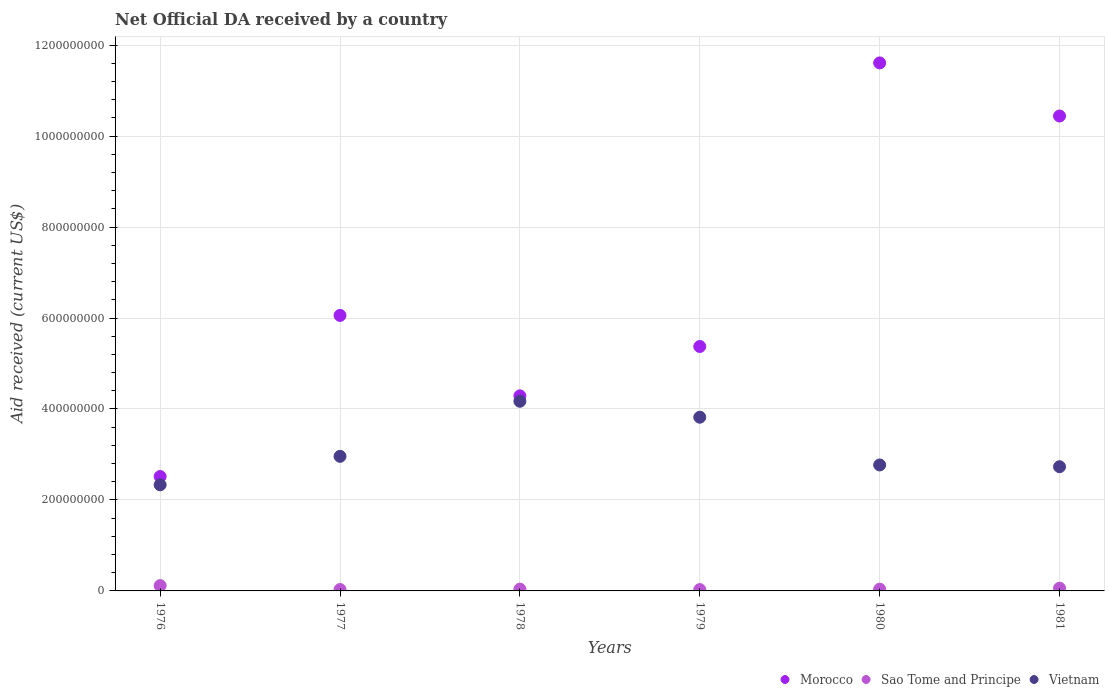Is the number of dotlines equal to the number of legend labels?
Your answer should be compact. Yes. What is the net official development assistance aid received in Sao Tome and Principe in 1980?
Your answer should be very brief. 3.82e+06. Across all years, what is the maximum net official development assistance aid received in Sao Tome and Principe?
Offer a terse response. 1.16e+07. Across all years, what is the minimum net official development assistance aid received in Sao Tome and Principe?
Make the answer very short. 2.95e+06. In which year was the net official development assistance aid received in Vietnam maximum?
Offer a very short reply. 1978. In which year was the net official development assistance aid received in Vietnam minimum?
Provide a short and direct response. 1976. What is the total net official development assistance aid received in Vietnam in the graph?
Give a very brief answer. 1.88e+09. What is the difference between the net official development assistance aid received in Morocco in 1979 and that in 1981?
Your response must be concise. -5.07e+08. What is the difference between the net official development assistance aid received in Vietnam in 1979 and the net official development assistance aid received in Sao Tome and Principe in 1980?
Keep it short and to the point. 3.78e+08. What is the average net official development assistance aid received in Vietnam per year?
Your response must be concise. 3.13e+08. In the year 1976, what is the difference between the net official development assistance aid received in Morocco and net official development assistance aid received in Vietnam?
Provide a short and direct response. 1.82e+07. What is the ratio of the net official development assistance aid received in Morocco in 1977 to that in 1978?
Ensure brevity in your answer.  1.41. Is the difference between the net official development assistance aid received in Morocco in 1976 and 1979 greater than the difference between the net official development assistance aid received in Vietnam in 1976 and 1979?
Make the answer very short. No. What is the difference between the highest and the second highest net official development assistance aid received in Vietnam?
Your answer should be very brief. 3.50e+07. What is the difference between the highest and the lowest net official development assistance aid received in Morocco?
Your answer should be compact. 9.09e+08. Is the sum of the net official development assistance aid received in Vietnam in 1976 and 1981 greater than the maximum net official development assistance aid received in Morocco across all years?
Your response must be concise. No. What is the difference between two consecutive major ticks on the Y-axis?
Provide a short and direct response. 2.00e+08. Are the values on the major ticks of Y-axis written in scientific E-notation?
Provide a short and direct response. No. Does the graph contain grids?
Give a very brief answer. Yes. What is the title of the graph?
Keep it short and to the point. Net Official DA received by a country. What is the label or title of the X-axis?
Give a very brief answer. Years. What is the label or title of the Y-axis?
Provide a short and direct response. Aid received (current US$). What is the Aid received (current US$) of Morocco in 1976?
Keep it short and to the point. 2.52e+08. What is the Aid received (current US$) of Sao Tome and Principe in 1976?
Make the answer very short. 1.16e+07. What is the Aid received (current US$) in Vietnam in 1976?
Offer a terse response. 2.33e+08. What is the Aid received (current US$) in Morocco in 1977?
Your answer should be compact. 6.06e+08. What is the Aid received (current US$) in Sao Tome and Principe in 1977?
Provide a succinct answer. 3.04e+06. What is the Aid received (current US$) of Vietnam in 1977?
Your answer should be very brief. 2.96e+08. What is the Aid received (current US$) of Morocco in 1978?
Provide a short and direct response. 4.29e+08. What is the Aid received (current US$) of Sao Tome and Principe in 1978?
Make the answer very short. 3.98e+06. What is the Aid received (current US$) of Vietnam in 1978?
Provide a short and direct response. 4.17e+08. What is the Aid received (current US$) of Morocco in 1979?
Your response must be concise. 5.37e+08. What is the Aid received (current US$) of Sao Tome and Principe in 1979?
Your response must be concise. 2.95e+06. What is the Aid received (current US$) in Vietnam in 1979?
Offer a very short reply. 3.82e+08. What is the Aid received (current US$) of Morocco in 1980?
Provide a succinct answer. 1.16e+09. What is the Aid received (current US$) of Sao Tome and Principe in 1980?
Make the answer very short. 3.82e+06. What is the Aid received (current US$) in Vietnam in 1980?
Your answer should be very brief. 2.77e+08. What is the Aid received (current US$) in Morocco in 1981?
Make the answer very short. 1.04e+09. What is the Aid received (current US$) in Vietnam in 1981?
Ensure brevity in your answer.  2.73e+08. Across all years, what is the maximum Aid received (current US$) in Morocco?
Ensure brevity in your answer.  1.16e+09. Across all years, what is the maximum Aid received (current US$) in Sao Tome and Principe?
Provide a succinct answer. 1.16e+07. Across all years, what is the maximum Aid received (current US$) of Vietnam?
Ensure brevity in your answer.  4.17e+08. Across all years, what is the minimum Aid received (current US$) in Morocco?
Give a very brief answer. 2.52e+08. Across all years, what is the minimum Aid received (current US$) in Sao Tome and Principe?
Your response must be concise. 2.95e+06. Across all years, what is the minimum Aid received (current US$) of Vietnam?
Your response must be concise. 2.33e+08. What is the total Aid received (current US$) in Morocco in the graph?
Your answer should be very brief. 4.03e+09. What is the total Aid received (current US$) in Sao Tome and Principe in the graph?
Ensure brevity in your answer.  3.14e+07. What is the total Aid received (current US$) of Vietnam in the graph?
Your answer should be very brief. 1.88e+09. What is the difference between the Aid received (current US$) in Morocco in 1976 and that in 1977?
Ensure brevity in your answer.  -3.54e+08. What is the difference between the Aid received (current US$) in Sao Tome and Principe in 1976 and that in 1977?
Provide a succinct answer. 8.61e+06. What is the difference between the Aid received (current US$) of Vietnam in 1976 and that in 1977?
Your answer should be very brief. -6.26e+07. What is the difference between the Aid received (current US$) in Morocco in 1976 and that in 1978?
Your answer should be compact. -1.77e+08. What is the difference between the Aid received (current US$) in Sao Tome and Principe in 1976 and that in 1978?
Your response must be concise. 7.67e+06. What is the difference between the Aid received (current US$) of Vietnam in 1976 and that in 1978?
Give a very brief answer. -1.84e+08. What is the difference between the Aid received (current US$) in Morocco in 1976 and that in 1979?
Offer a terse response. -2.86e+08. What is the difference between the Aid received (current US$) of Sao Tome and Principe in 1976 and that in 1979?
Make the answer very short. 8.70e+06. What is the difference between the Aid received (current US$) in Vietnam in 1976 and that in 1979?
Your answer should be very brief. -1.49e+08. What is the difference between the Aid received (current US$) of Morocco in 1976 and that in 1980?
Ensure brevity in your answer.  -9.09e+08. What is the difference between the Aid received (current US$) in Sao Tome and Principe in 1976 and that in 1980?
Provide a short and direct response. 7.83e+06. What is the difference between the Aid received (current US$) in Vietnam in 1976 and that in 1980?
Your response must be concise. -4.36e+07. What is the difference between the Aid received (current US$) in Morocco in 1976 and that in 1981?
Provide a short and direct response. -7.93e+08. What is the difference between the Aid received (current US$) of Sao Tome and Principe in 1976 and that in 1981?
Give a very brief answer. 5.65e+06. What is the difference between the Aid received (current US$) of Vietnam in 1976 and that in 1981?
Your answer should be very brief. -3.98e+07. What is the difference between the Aid received (current US$) of Morocco in 1977 and that in 1978?
Your answer should be very brief. 1.77e+08. What is the difference between the Aid received (current US$) of Sao Tome and Principe in 1977 and that in 1978?
Your response must be concise. -9.40e+05. What is the difference between the Aid received (current US$) of Vietnam in 1977 and that in 1978?
Offer a very short reply. -1.21e+08. What is the difference between the Aid received (current US$) in Morocco in 1977 and that in 1979?
Offer a terse response. 6.83e+07. What is the difference between the Aid received (current US$) in Sao Tome and Principe in 1977 and that in 1979?
Ensure brevity in your answer.  9.00e+04. What is the difference between the Aid received (current US$) of Vietnam in 1977 and that in 1979?
Give a very brief answer. -8.60e+07. What is the difference between the Aid received (current US$) of Morocco in 1977 and that in 1980?
Offer a very short reply. -5.55e+08. What is the difference between the Aid received (current US$) of Sao Tome and Principe in 1977 and that in 1980?
Your answer should be compact. -7.80e+05. What is the difference between the Aid received (current US$) of Vietnam in 1977 and that in 1980?
Provide a short and direct response. 1.90e+07. What is the difference between the Aid received (current US$) in Morocco in 1977 and that in 1981?
Provide a succinct answer. -4.38e+08. What is the difference between the Aid received (current US$) in Sao Tome and Principe in 1977 and that in 1981?
Offer a terse response. -2.96e+06. What is the difference between the Aid received (current US$) of Vietnam in 1977 and that in 1981?
Give a very brief answer. 2.28e+07. What is the difference between the Aid received (current US$) of Morocco in 1978 and that in 1979?
Ensure brevity in your answer.  -1.09e+08. What is the difference between the Aid received (current US$) in Sao Tome and Principe in 1978 and that in 1979?
Give a very brief answer. 1.03e+06. What is the difference between the Aid received (current US$) of Vietnam in 1978 and that in 1979?
Make the answer very short. 3.50e+07. What is the difference between the Aid received (current US$) in Morocco in 1978 and that in 1980?
Keep it short and to the point. -7.32e+08. What is the difference between the Aid received (current US$) in Vietnam in 1978 and that in 1980?
Make the answer very short. 1.40e+08. What is the difference between the Aid received (current US$) in Morocco in 1978 and that in 1981?
Your response must be concise. -6.15e+08. What is the difference between the Aid received (current US$) of Sao Tome and Principe in 1978 and that in 1981?
Ensure brevity in your answer.  -2.02e+06. What is the difference between the Aid received (current US$) of Vietnam in 1978 and that in 1981?
Keep it short and to the point. 1.44e+08. What is the difference between the Aid received (current US$) of Morocco in 1979 and that in 1980?
Ensure brevity in your answer.  -6.23e+08. What is the difference between the Aid received (current US$) of Sao Tome and Principe in 1979 and that in 1980?
Ensure brevity in your answer.  -8.70e+05. What is the difference between the Aid received (current US$) of Vietnam in 1979 and that in 1980?
Offer a very short reply. 1.05e+08. What is the difference between the Aid received (current US$) in Morocco in 1979 and that in 1981?
Ensure brevity in your answer.  -5.07e+08. What is the difference between the Aid received (current US$) of Sao Tome and Principe in 1979 and that in 1981?
Offer a very short reply. -3.05e+06. What is the difference between the Aid received (current US$) of Vietnam in 1979 and that in 1981?
Offer a very short reply. 1.09e+08. What is the difference between the Aid received (current US$) in Morocco in 1980 and that in 1981?
Your answer should be very brief. 1.17e+08. What is the difference between the Aid received (current US$) of Sao Tome and Principe in 1980 and that in 1981?
Your response must be concise. -2.18e+06. What is the difference between the Aid received (current US$) in Vietnam in 1980 and that in 1981?
Make the answer very short. 3.85e+06. What is the difference between the Aid received (current US$) of Morocco in 1976 and the Aid received (current US$) of Sao Tome and Principe in 1977?
Give a very brief answer. 2.48e+08. What is the difference between the Aid received (current US$) in Morocco in 1976 and the Aid received (current US$) in Vietnam in 1977?
Give a very brief answer. -4.44e+07. What is the difference between the Aid received (current US$) of Sao Tome and Principe in 1976 and the Aid received (current US$) of Vietnam in 1977?
Give a very brief answer. -2.84e+08. What is the difference between the Aid received (current US$) in Morocco in 1976 and the Aid received (current US$) in Sao Tome and Principe in 1978?
Your response must be concise. 2.48e+08. What is the difference between the Aid received (current US$) in Morocco in 1976 and the Aid received (current US$) in Vietnam in 1978?
Offer a very short reply. -1.65e+08. What is the difference between the Aid received (current US$) of Sao Tome and Principe in 1976 and the Aid received (current US$) of Vietnam in 1978?
Give a very brief answer. -4.05e+08. What is the difference between the Aid received (current US$) of Morocco in 1976 and the Aid received (current US$) of Sao Tome and Principe in 1979?
Offer a terse response. 2.49e+08. What is the difference between the Aid received (current US$) of Morocco in 1976 and the Aid received (current US$) of Vietnam in 1979?
Provide a succinct answer. -1.30e+08. What is the difference between the Aid received (current US$) of Sao Tome and Principe in 1976 and the Aid received (current US$) of Vietnam in 1979?
Provide a succinct answer. -3.70e+08. What is the difference between the Aid received (current US$) of Morocco in 1976 and the Aid received (current US$) of Sao Tome and Principe in 1980?
Your response must be concise. 2.48e+08. What is the difference between the Aid received (current US$) in Morocco in 1976 and the Aid received (current US$) in Vietnam in 1980?
Offer a very short reply. -2.54e+07. What is the difference between the Aid received (current US$) of Sao Tome and Principe in 1976 and the Aid received (current US$) of Vietnam in 1980?
Provide a short and direct response. -2.65e+08. What is the difference between the Aid received (current US$) of Morocco in 1976 and the Aid received (current US$) of Sao Tome and Principe in 1981?
Offer a terse response. 2.46e+08. What is the difference between the Aid received (current US$) in Morocco in 1976 and the Aid received (current US$) in Vietnam in 1981?
Offer a terse response. -2.16e+07. What is the difference between the Aid received (current US$) of Sao Tome and Principe in 1976 and the Aid received (current US$) of Vietnam in 1981?
Your response must be concise. -2.61e+08. What is the difference between the Aid received (current US$) of Morocco in 1977 and the Aid received (current US$) of Sao Tome and Principe in 1978?
Keep it short and to the point. 6.02e+08. What is the difference between the Aid received (current US$) of Morocco in 1977 and the Aid received (current US$) of Vietnam in 1978?
Your answer should be very brief. 1.89e+08. What is the difference between the Aid received (current US$) in Sao Tome and Principe in 1977 and the Aid received (current US$) in Vietnam in 1978?
Ensure brevity in your answer.  -4.14e+08. What is the difference between the Aid received (current US$) in Morocco in 1977 and the Aid received (current US$) in Sao Tome and Principe in 1979?
Your answer should be very brief. 6.03e+08. What is the difference between the Aid received (current US$) of Morocco in 1977 and the Aid received (current US$) of Vietnam in 1979?
Provide a short and direct response. 2.24e+08. What is the difference between the Aid received (current US$) of Sao Tome and Principe in 1977 and the Aid received (current US$) of Vietnam in 1979?
Provide a succinct answer. -3.79e+08. What is the difference between the Aid received (current US$) of Morocco in 1977 and the Aid received (current US$) of Sao Tome and Principe in 1980?
Provide a short and direct response. 6.02e+08. What is the difference between the Aid received (current US$) in Morocco in 1977 and the Aid received (current US$) in Vietnam in 1980?
Make the answer very short. 3.29e+08. What is the difference between the Aid received (current US$) of Sao Tome and Principe in 1977 and the Aid received (current US$) of Vietnam in 1980?
Offer a very short reply. -2.74e+08. What is the difference between the Aid received (current US$) in Morocco in 1977 and the Aid received (current US$) in Sao Tome and Principe in 1981?
Your answer should be compact. 6.00e+08. What is the difference between the Aid received (current US$) in Morocco in 1977 and the Aid received (current US$) in Vietnam in 1981?
Your answer should be very brief. 3.33e+08. What is the difference between the Aid received (current US$) in Sao Tome and Principe in 1977 and the Aid received (current US$) in Vietnam in 1981?
Your answer should be very brief. -2.70e+08. What is the difference between the Aid received (current US$) in Morocco in 1978 and the Aid received (current US$) in Sao Tome and Principe in 1979?
Your answer should be compact. 4.26e+08. What is the difference between the Aid received (current US$) of Morocco in 1978 and the Aid received (current US$) of Vietnam in 1979?
Offer a very short reply. 4.69e+07. What is the difference between the Aid received (current US$) in Sao Tome and Principe in 1978 and the Aid received (current US$) in Vietnam in 1979?
Keep it short and to the point. -3.78e+08. What is the difference between the Aid received (current US$) in Morocco in 1978 and the Aid received (current US$) in Sao Tome and Principe in 1980?
Make the answer very short. 4.25e+08. What is the difference between the Aid received (current US$) in Morocco in 1978 and the Aid received (current US$) in Vietnam in 1980?
Your response must be concise. 1.52e+08. What is the difference between the Aid received (current US$) in Sao Tome and Principe in 1978 and the Aid received (current US$) in Vietnam in 1980?
Offer a terse response. -2.73e+08. What is the difference between the Aid received (current US$) in Morocco in 1978 and the Aid received (current US$) in Sao Tome and Principe in 1981?
Make the answer very short. 4.23e+08. What is the difference between the Aid received (current US$) in Morocco in 1978 and the Aid received (current US$) in Vietnam in 1981?
Offer a terse response. 1.56e+08. What is the difference between the Aid received (current US$) of Sao Tome and Principe in 1978 and the Aid received (current US$) of Vietnam in 1981?
Provide a succinct answer. -2.69e+08. What is the difference between the Aid received (current US$) in Morocco in 1979 and the Aid received (current US$) in Sao Tome and Principe in 1980?
Provide a succinct answer. 5.34e+08. What is the difference between the Aid received (current US$) of Morocco in 1979 and the Aid received (current US$) of Vietnam in 1980?
Offer a terse response. 2.60e+08. What is the difference between the Aid received (current US$) in Sao Tome and Principe in 1979 and the Aid received (current US$) in Vietnam in 1980?
Provide a succinct answer. -2.74e+08. What is the difference between the Aid received (current US$) of Morocco in 1979 and the Aid received (current US$) of Sao Tome and Principe in 1981?
Offer a terse response. 5.31e+08. What is the difference between the Aid received (current US$) of Morocco in 1979 and the Aid received (current US$) of Vietnam in 1981?
Provide a succinct answer. 2.64e+08. What is the difference between the Aid received (current US$) of Sao Tome and Principe in 1979 and the Aid received (current US$) of Vietnam in 1981?
Your answer should be compact. -2.70e+08. What is the difference between the Aid received (current US$) of Morocco in 1980 and the Aid received (current US$) of Sao Tome and Principe in 1981?
Your answer should be compact. 1.15e+09. What is the difference between the Aid received (current US$) of Morocco in 1980 and the Aid received (current US$) of Vietnam in 1981?
Give a very brief answer. 8.88e+08. What is the difference between the Aid received (current US$) in Sao Tome and Principe in 1980 and the Aid received (current US$) in Vietnam in 1981?
Provide a succinct answer. -2.69e+08. What is the average Aid received (current US$) in Morocco per year?
Give a very brief answer. 6.71e+08. What is the average Aid received (current US$) in Sao Tome and Principe per year?
Provide a succinct answer. 5.24e+06. What is the average Aid received (current US$) of Vietnam per year?
Keep it short and to the point. 3.13e+08. In the year 1976, what is the difference between the Aid received (current US$) of Morocco and Aid received (current US$) of Sao Tome and Principe?
Make the answer very short. 2.40e+08. In the year 1976, what is the difference between the Aid received (current US$) in Morocco and Aid received (current US$) in Vietnam?
Ensure brevity in your answer.  1.82e+07. In the year 1976, what is the difference between the Aid received (current US$) of Sao Tome and Principe and Aid received (current US$) of Vietnam?
Provide a short and direct response. -2.22e+08. In the year 1977, what is the difference between the Aid received (current US$) of Morocco and Aid received (current US$) of Sao Tome and Principe?
Provide a succinct answer. 6.03e+08. In the year 1977, what is the difference between the Aid received (current US$) of Morocco and Aid received (current US$) of Vietnam?
Offer a very short reply. 3.10e+08. In the year 1977, what is the difference between the Aid received (current US$) of Sao Tome and Principe and Aid received (current US$) of Vietnam?
Your answer should be compact. -2.93e+08. In the year 1978, what is the difference between the Aid received (current US$) in Morocco and Aid received (current US$) in Sao Tome and Principe?
Offer a terse response. 4.25e+08. In the year 1978, what is the difference between the Aid received (current US$) in Morocco and Aid received (current US$) in Vietnam?
Provide a short and direct response. 1.19e+07. In the year 1978, what is the difference between the Aid received (current US$) of Sao Tome and Principe and Aid received (current US$) of Vietnam?
Ensure brevity in your answer.  -4.13e+08. In the year 1979, what is the difference between the Aid received (current US$) of Morocco and Aid received (current US$) of Sao Tome and Principe?
Keep it short and to the point. 5.34e+08. In the year 1979, what is the difference between the Aid received (current US$) in Morocco and Aid received (current US$) in Vietnam?
Your answer should be very brief. 1.55e+08. In the year 1979, what is the difference between the Aid received (current US$) of Sao Tome and Principe and Aid received (current US$) of Vietnam?
Make the answer very short. -3.79e+08. In the year 1980, what is the difference between the Aid received (current US$) of Morocco and Aid received (current US$) of Sao Tome and Principe?
Provide a succinct answer. 1.16e+09. In the year 1980, what is the difference between the Aid received (current US$) of Morocco and Aid received (current US$) of Vietnam?
Keep it short and to the point. 8.84e+08. In the year 1980, what is the difference between the Aid received (current US$) of Sao Tome and Principe and Aid received (current US$) of Vietnam?
Make the answer very short. -2.73e+08. In the year 1981, what is the difference between the Aid received (current US$) of Morocco and Aid received (current US$) of Sao Tome and Principe?
Give a very brief answer. 1.04e+09. In the year 1981, what is the difference between the Aid received (current US$) in Morocco and Aid received (current US$) in Vietnam?
Offer a very short reply. 7.71e+08. In the year 1981, what is the difference between the Aid received (current US$) of Sao Tome and Principe and Aid received (current US$) of Vietnam?
Your answer should be very brief. -2.67e+08. What is the ratio of the Aid received (current US$) of Morocco in 1976 to that in 1977?
Provide a succinct answer. 0.42. What is the ratio of the Aid received (current US$) in Sao Tome and Principe in 1976 to that in 1977?
Offer a very short reply. 3.83. What is the ratio of the Aid received (current US$) in Vietnam in 1976 to that in 1977?
Offer a very short reply. 0.79. What is the ratio of the Aid received (current US$) in Morocco in 1976 to that in 1978?
Your answer should be very brief. 0.59. What is the ratio of the Aid received (current US$) of Sao Tome and Principe in 1976 to that in 1978?
Make the answer very short. 2.93. What is the ratio of the Aid received (current US$) in Vietnam in 1976 to that in 1978?
Provide a succinct answer. 0.56. What is the ratio of the Aid received (current US$) in Morocco in 1976 to that in 1979?
Give a very brief answer. 0.47. What is the ratio of the Aid received (current US$) in Sao Tome and Principe in 1976 to that in 1979?
Make the answer very short. 3.95. What is the ratio of the Aid received (current US$) in Vietnam in 1976 to that in 1979?
Your answer should be compact. 0.61. What is the ratio of the Aid received (current US$) in Morocco in 1976 to that in 1980?
Your answer should be compact. 0.22. What is the ratio of the Aid received (current US$) of Sao Tome and Principe in 1976 to that in 1980?
Your answer should be compact. 3.05. What is the ratio of the Aid received (current US$) in Vietnam in 1976 to that in 1980?
Provide a succinct answer. 0.84. What is the ratio of the Aid received (current US$) of Morocco in 1976 to that in 1981?
Your answer should be very brief. 0.24. What is the ratio of the Aid received (current US$) of Sao Tome and Principe in 1976 to that in 1981?
Offer a very short reply. 1.94. What is the ratio of the Aid received (current US$) in Vietnam in 1976 to that in 1981?
Your answer should be very brief. 0.85. What is the ratio of the Aid received (current US$) in Morocco in 1977 to that in 1978?
Provide a succinct answer. 1.41. What is the ratio of the Aid received (current US$) in Sao Tome and Principe in 1977 to that in 1978?
Ensure brevity in your answer.  0.76. What is the ratio of the Aid received (current US$) of Vietnam in 1977 to that in 1978?
Your answer should be very brief. 0.71. What is the ratio of the Aid received (current US$) of Morocco in 1977 to that in 1979?
Your response must be concise. 1.13. What is the ratio of the Aid received (current US$) of Sao Tome and Principe in 1977 to that in 1979?
Provide a succinct answer. 1.03. What is the ratio of the Aid received (current US$) of Vietnam in 1977 to that in 1979?
Make the answer very short. 0.77. What is the ratio of the Aid received (current US$) in Morocco in 1977 to that in 1980?
Your response must be concise. 0.52. What is the ratio of the Aid received (current US$) of Sao Tome and Principe in 1977 to that in 1980?
Provide a succinct answer. 0.8. What is the ratio of the Aid received (current US$) in Vietnam in 1977 to that in 1980?
Provide a short and direct response. 1.07. What is the ratio of the Aid received (current US$) of Morocco in 1977 to that in 1981?
Your response must be concise. 0.58. What is the ratio of the Aid received (current US$) in Sao Tome and Principe in 1977 to that in 1981?
Your answer should be compact. 0.51. What is the ratio of the Aid received (current US$) of Vietnam in 1977 to that in 1981?
Provide a succinct answer. 1.08. What is the ratio of the Aid received (current US$) of Morocco in 1978 to that in 1979?
Offer a very short reply. 0.8. What is the ratio of the Aid received (current US$) in Sao Tome and Principe in 1978 to that in 1979?
Your answer should be compact. 1.35. What is the ratio of the Aid received (current US$) in Vietnam in 1978 to that in 1979?
Ensure brevity in your answer.  1.09. What is the ratio of the Aid received (current US$) in Morocco in 1978 to that in 1980?
Keep it short and to the point. 0.37. What is the ratio of the Aid received (current US$) in Sao Tome and Principe in 1978 to that in 1980?
Your answer should be very brief. 1.04. What is the ratio of the Aid received (current US$) of Vietnam in 1978 to that in 1980?
Ensure brevity in your answer.  1.51. What is the ratio of the Aid received (current US$) of Morocco in 1978 to that in 1981?
Offer a very short reply. 0.41. What is the ratio of the Aid received (current US$) in Sao Tome and Principe in 1978 to that in 1981?
Offer a very short reply. 0.66. What is the ratio of the Aid received (current US$) of Vietnam in 1978 to that in 1981?
Your response must be concise. 1.53. What is the ratio of the Aid received (current US$) in Morocco in 1979 to that in 1980?
Keep it short and to the point. 0.46. What is the ratio of the Aid received (current US$) of Sao Tome and Principe in 1979 to that in 1980?
Offer a very short reply. 0.77. What is the ratio of the Aid received (current US$) in Vietnam in 1979 to that in 1980?
Offer a terse response. 1.38. What is the ratio of the Aid received (current US$) of Morocco in 1979 to that in 1981?
Offer a very short reply. 0.51. What is the ratio of the Aid received (current US$) of Sao Tome and Principe in 1979 to that in 1981?
Your answer should be compact. 0.49. What is the ratio of the Aid received (current US$) of Vietnam in 1979 to that in 1981?
Provide a short and direct response. 1.4. What is the ratio of the Aid received (current US$) of Morocco in 1980 to that in 1981?
Offer a terse response. 1.11. What is the ratio of the Aid received (current US$) in Sao Tome and Principe in 1980 to that in 1981?
Your answer should be compact. 0.64. What is the ratio of the Aid received (current US$) of Vietnam in 1980 to that in 1981?
Ensure brevity in your answer.  1.01. What is the difference between the highest and the second highest Aid received (current US$) of Morocco?
Provide a succinct answer. 1.17e+08. What is the difference between the highest and the second highest Aid received (current US$) of Sao Tome and Principe?
Make the answer very short. 5.65e+06. What is the difference between the highest and the second highest Aid received (current US$) of Vietnam?
Provide a succinct answer. 3.50e+07. What is the difference between the highest and the lowest Aid received (current US$) in Morocco?
Provide a short and direct response. 9.09e+08. What is the difference between the highest and the lowest Aid received (current US$) in Sao Tome and Principe?
Provide a short and direct response. 8.70e+06. What is the difference between the highest and the lowest Aid received (current US$) in Vietnam?
Ensure brevity in your answer.  1.84e+08. 